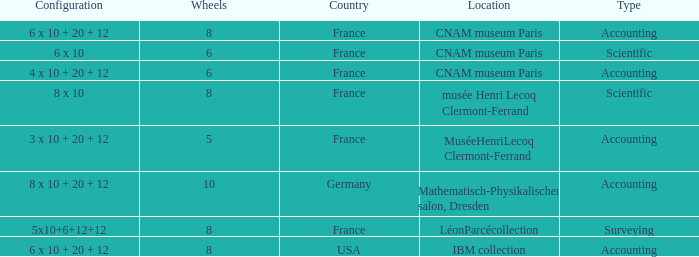What location has surveying as the type? LéonParcécollection. Would you be able to parse every entry in this table? {'header': ['Configuration', 'Wheels', 'Country', 'Location', 'Type'], 'rows': [['6 x 10 + 20 + 12', '8', 'France', 'CNAM museum Paris', 'Accounting'], ['6 x 10', '6', 'France', 'CNAM museum Paris', 'Scientific'], ['4 x 10 + 20 + 12', '6', 'France', 'CNAM museum Paris', 'Accounting'], ['8 x 10', '8', 'France', 'musée Henri Lecoq Clermont-Ferrand', 'Scientific'], ['3 x 10 + 20 + 12', '5', 'France', 'MuséeHenriLecoq Clermont-Ferrand', 'Accounting'], ['8 x 10 + 20 + 12', '10', 'Germany', 'Mathematisch-Physikalischer salon, Dresden', 'Accounting'], ['5x10+6+12+12', '8', 'France', 'LéonParcécollection', 'Surveying'], ['6 x 10 + 20 + 12', '8', 'USA', 'IBM collection', 'Accounting']]} 